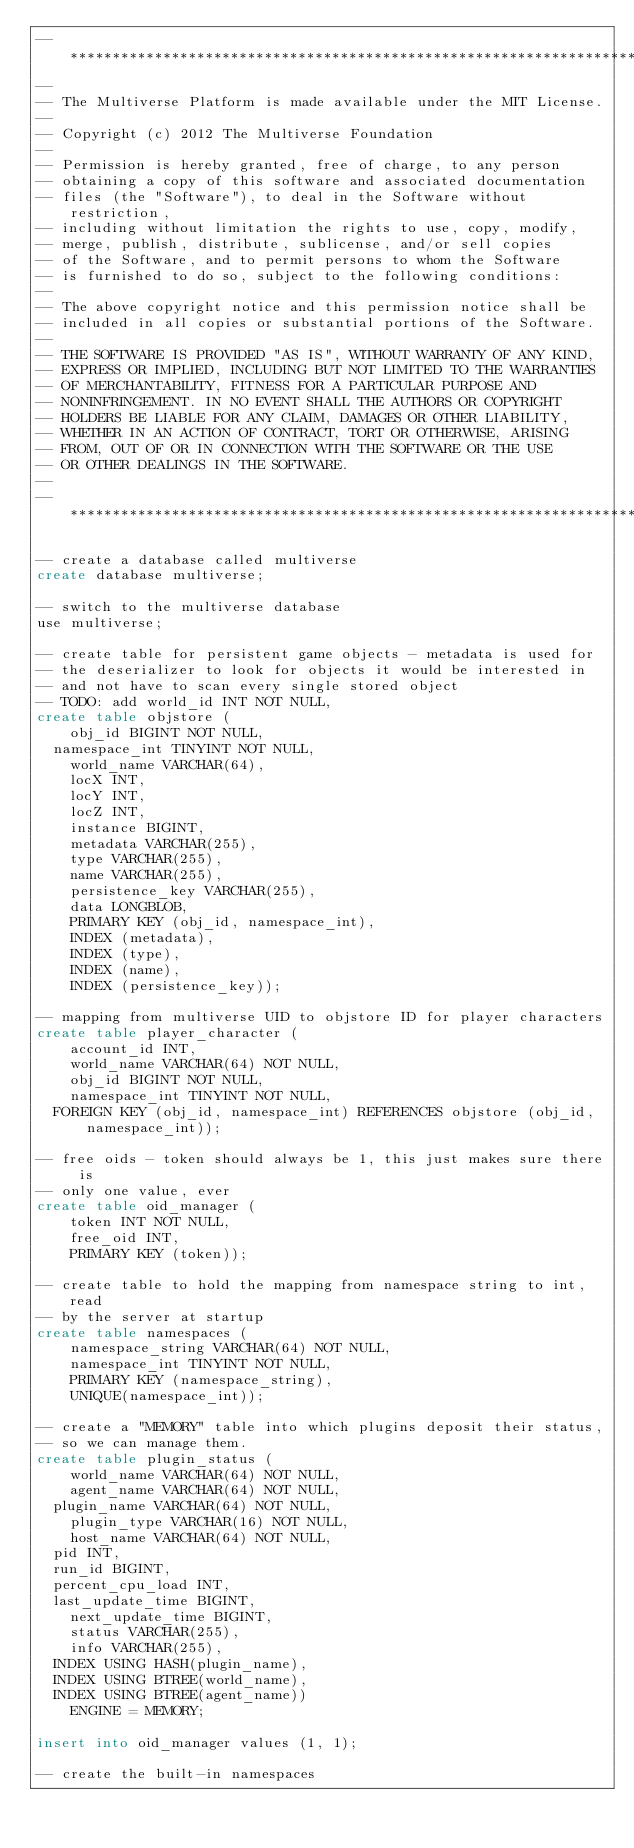Convert code to text. <code><loc_0><loc_0><loc_500><loc_500><_SQL_>-- *******************************************************************
--
-- The Multiverse Platform is made available under the MIT License.
--
-- Copyright (c) 2012 The Multiverse Foundation
-- 
-- Permission is hereby granted, free of charge, to any person 
-- obtaining a copy of this software and associated documentation 
-- files (the "Software"), to deal in the Software without restriction, 
-- including without limitation the rights to use, copy, modify, 
-- merge, publish, distribute, sublicense, and/or sell copies 
-- of the Software, and to permit persons to whom the Software 
-- is furnished to do so, subject to the following conditions:
-- 
-- The above copyright notice and this permission notice shall be 
-- included in all copies or substantial portions of the Software.
-- 
-- THE SOFTWARE IS PROVIDED "AS IS", WITHOUT WARRANTY OF ANY KIND, 
-- EXPRESS OR IMPLIED, INCLUDING BUT NOT LIMITED TO THE WARRANTIES 
-- OF MERCHANTABILITY, FITNESS FOR A PARTICULAR PURPOSE AND 
-- NONINFRINGEMENT. IN NO EVENT SHALL THE AUTHORS OR COPYRIGHT 
-- HOLDERS BE LIABLE FOR ANY CLAIM, DAMAGES OR OTHER LIABILITY, 
-- WHETHER IN AN ACTION OF CONTRACT, TORT OR OTHERWISE, ARISING 
-- FROM, OUT OF OR IN CONNECTION WITH THE SOFTWARE OR THE USE 
-- OR OTHER DEALINGS IN THE SOFTWARE.
-- 
-- ********************************************************************

-- create a database called multiverse
create database multiverse;

-- switch to the multiverse database
use multiverse;

-- create table for persistent game objects - metadata is used for
-- the deserializer to look for objects it would be interested in
-- and not have to scan every single stored object
-- TODO: add world_id INT NOT NULL,
create table objstore (
    obj_id BIGINT NOT NULL,
	namespace_int TINYINT NOT NULL,
    world_name VARCHAR(64),
    locX INT,
    locY INT,
    locZ INT,
    instance BIGINT,
    metadata VARCHAR(255),
    type VARCHAR(255),
    name VARCHAR(255),
    persistence_key VARCHAR(255),
    data LONGBLOB,
    PRIMARY KEY (obj_id, namespace_int),
    INDEX (metadata),
    INDEX (type),
    INDEX (name),
    INDEX (persistence_key));

-- mapping from multiverse UID to objstore ID for player characters
create table player_character (
    account_id INT,
    world_name VARCHAR(64) NOT NULL,
    obj_id BIGINT NOT NULL,
    namespace_int TINYINT NOT NULL,
	FOREIGN KEY (obj_id, namespace_int) REFERENCES objstore (obj_id, namespace_int));

-- free oids - token should always be 1, this just makes sure there is 
-- only one value, ever
create table oid_manager (
    token INT NOT NULL,
    free_oid INT,
    PRIMARY KEY (token));

-- create table to hold the mapping from namespace string to int, read
-- by the server at startup
create table namespaces (
    namespace_string VARCHAR(64) NOT NULL,
    namespace_int TINYINT NOT NULL,
    PRIMARY KEY (namespace_string),
    UNIQUE(namespace_int));

-- create a "MEMORY" table into which plugins deposit their status, 
-- so we can manage them.
create table plugin_status (
    world_name VARCHAR(64) NOT NULL,
    agent_name VARCHAR(64) NOT NULL,
	plugin_name VARCHAR(64) NOT NULL,
    plugin_type VARCHAR(16) NOT NULL,
    host_name VARCHAR(64) NOT NULL,
	pid INT,
	run_id BIGINT,
	percent_cpu_load INT,
	last_update_time BIGINT,
    next_update_time BIGINT,
    status VARCHAR(255),
    info VARCHAR(255),
	INDEX USING HASH(plugin_name),
	INDEX USING BTREE(world_name),
	INDEX USING BTREE(agent_name))
    ENGINE = MEMORY;

insert into oid_manager values (1, 1);

-- create the built-in namespaces</code> 